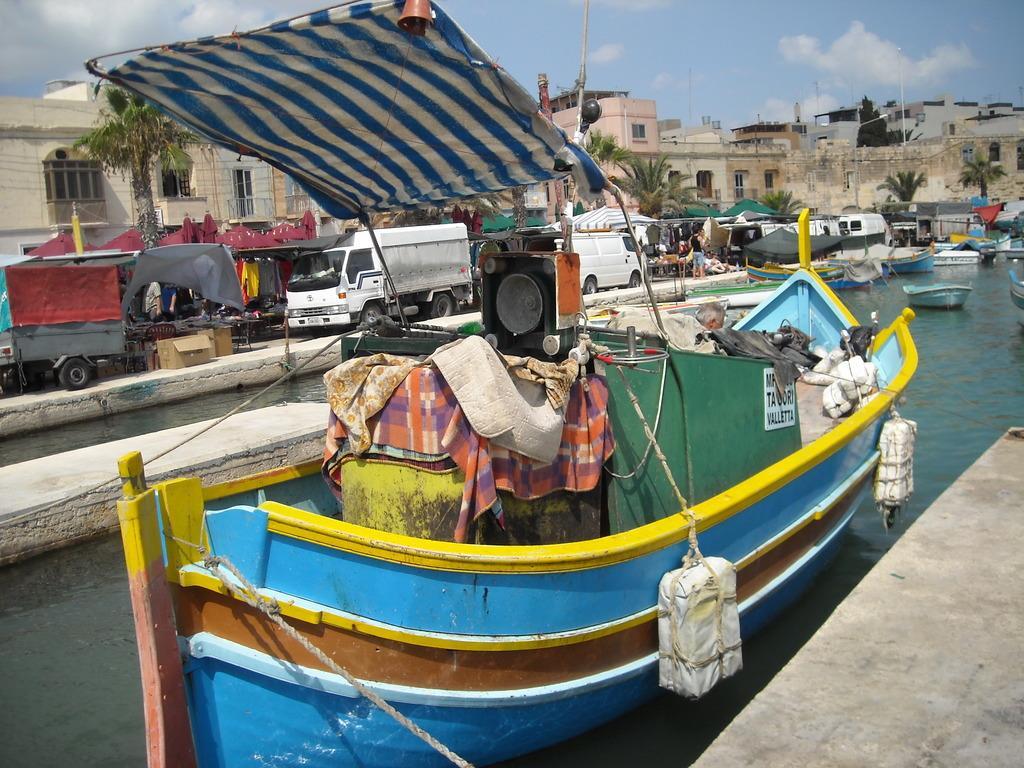In one or two sentences, can you explain what this image depicts? In this image, we can see tents, clothes and some other objects are on the boat and in the background, there are many boats and we can see vehicles, tents, buildings, trees and poles. At the bottom, there is water and at the top, there are clouds in the sky. 